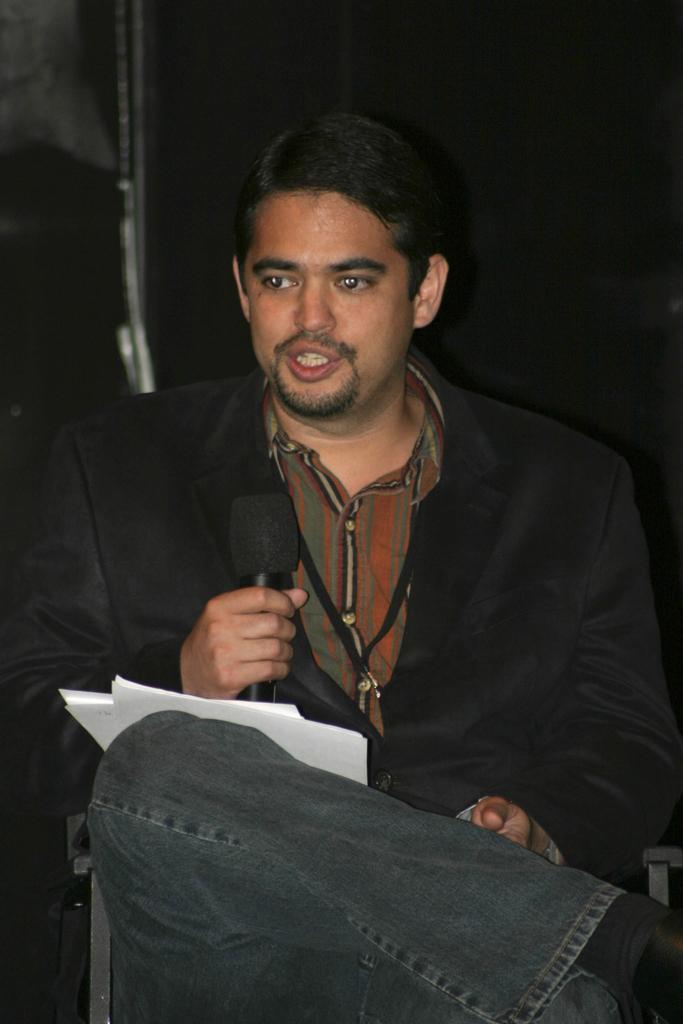Can you describe this image briefly? In this picture I can observe a man in the middle of the picture. He is sitting on the chair. He is holding a mic in his hand. The background is dark. 